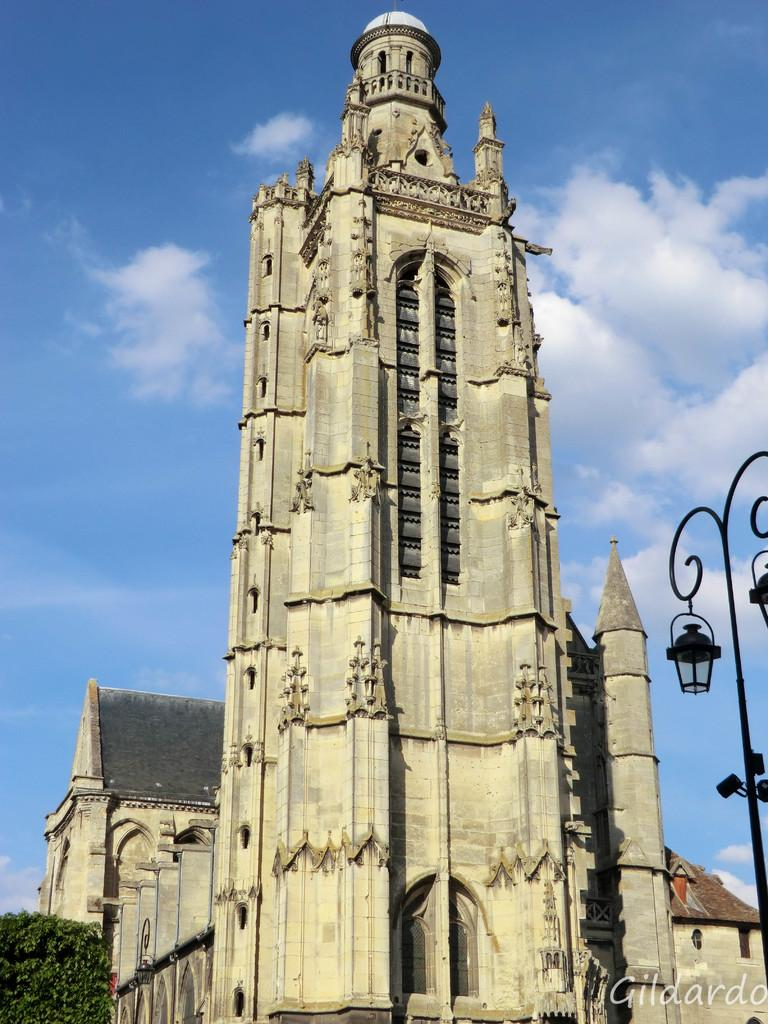What type of structures can be seen in the image? There are buildings in the image. What type of lighting is present in the image? There are street lamps in the image. Where is the tree located in the image? The tree is on the left side of the image. What is visible at the top of the image? The sky is visible at the top of the image. What can be seen in the sky? There are clouds in the sky. What type of oil is being used to fuel the street lamps in the image? There is no information about the type of oil being used to fuel the street lamps in the image, and street lamps are typically powered by electricity. Can you see an argument taking place between the buildings in the image? There is no indication of an argument or any human interaction in the image; it only shows buildings, street lamps, a tree, and the sky. 